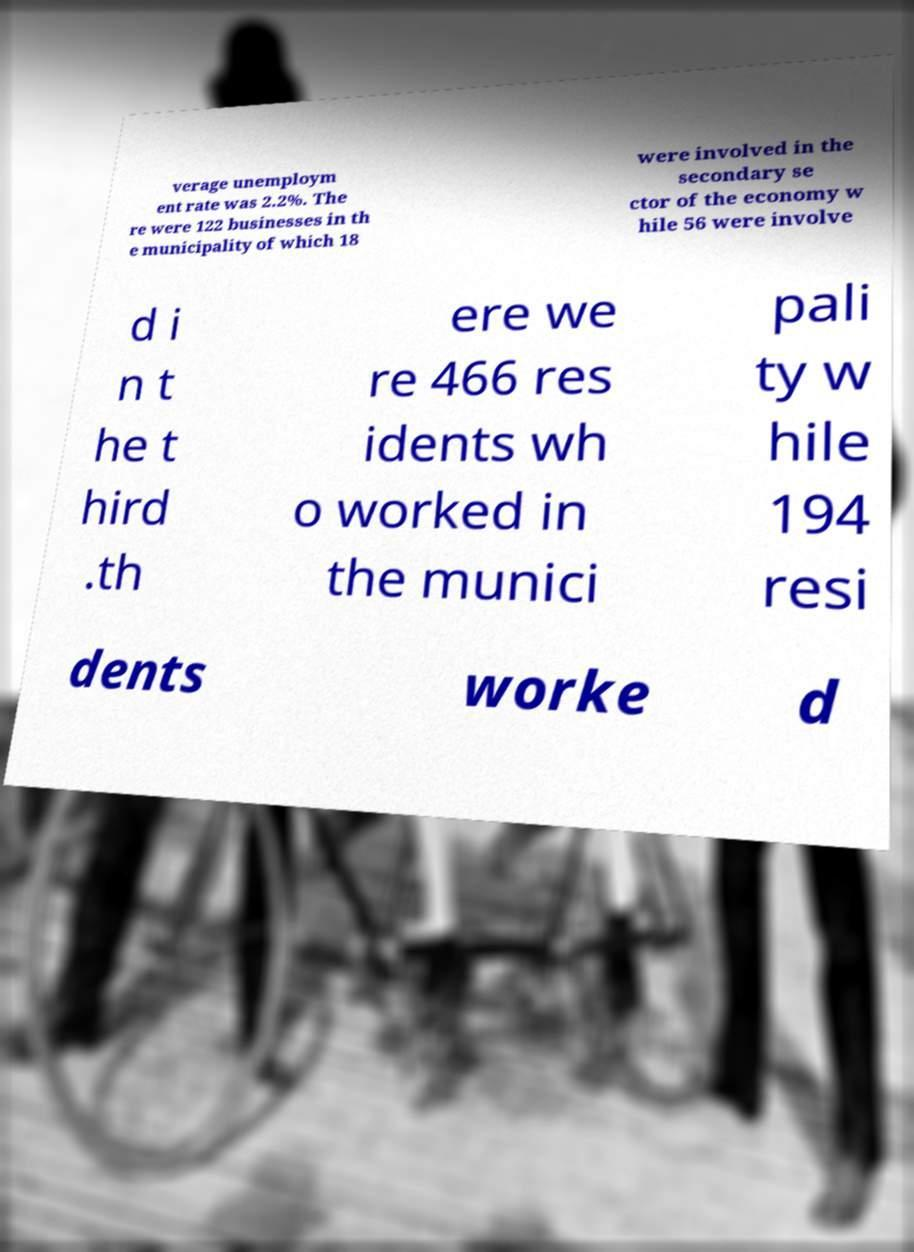Can you read and provide the text displayed in the image?This photo seems to have some interesting text. Can you extract and type it out for me? verage unemploym ent rate was 2.2%. The re were 122 businesses in th e municipality of which 18 were involved in the secondary se ctor of the economy w hile 56 were involve d i n t he t hird .th ere we re 466 res idents wh o worked in the munici pali ty w hile 194 resi dents worke d 